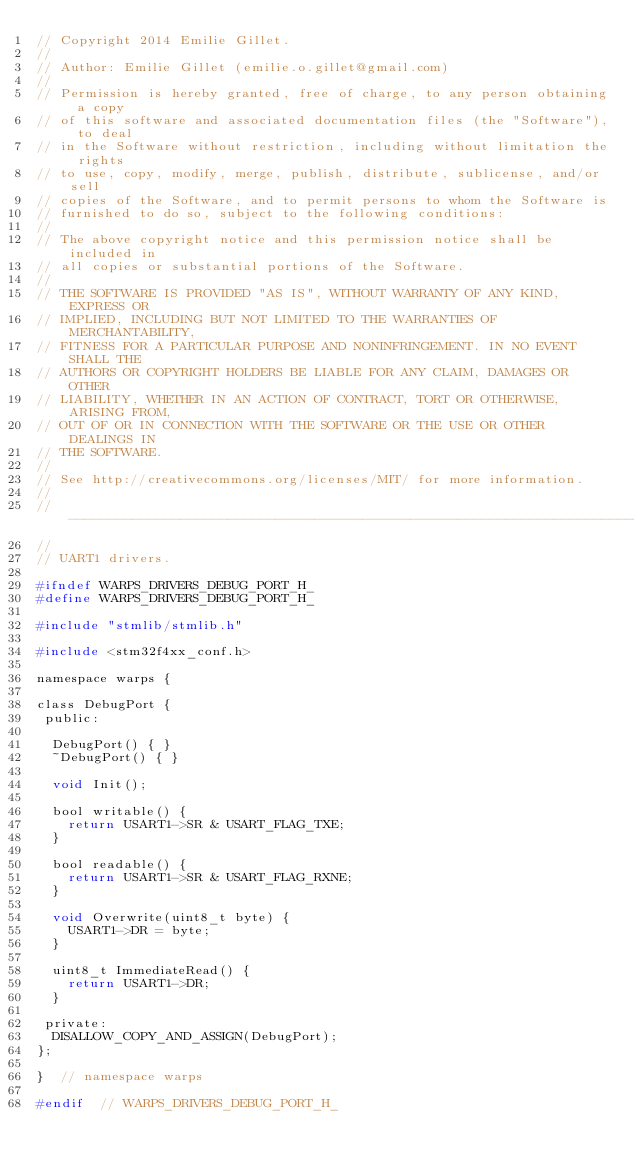<code> <loc_0><loc_0><loc_500><loc_500><_C_>// Copyright 2014 Emilie Gillet.
//
// Author: Emilie Gillet (emilie.o.gillet@gmail.com)
//
// Permission is hereby granted, free of charge, to any person obtaining a copy
// of this software and associated documentation files (the "Software"), to deal
// in the Software without restriction, including without limitation the rights
// to use, copy, modify, merge, publish, distribute, sublicense, and/or sell
// copies of the Software, and to permit persons to whom the Software is
// furnished to do so, subject to the following conditions:
// 
// The above copyright notice and this permission notice shall be included in
// all copies or substantial portions of the Software.
// 
// THE SOFTWARE IS PROVIDED "AS IS", WITHOUT WARRANTY OF ANY KIND, EXPRESS OR
// IMPLIED, INCLUDING BUT NOT LIMITED TO THE WARRANTIES OF MERCHANTABILITY,
// FITNESS FOR A PARTICULAR PURPOSE AND NONINFRINGEMENT. IN NO EVENT SHALL THE
// AUTHORS OR COPYRIGHT HOLDERS BE LIABLE FOR ANY CLAIM, DAMAGES OR OTHER
// LIABILITY, WHETHER IN AN ACTION OF CONTRACT, TORT OR OTHERWISE, ARISING FROM,
// OUT OF OR IN CONNECTION WITH THE SOFTWARE OR THE USE OR OTHER DEALINGS IN
// THE SOFTWARE.
// 
// See http://creativecommons.org/licenses/MIT/ for more information.
//
// -----------------------------------------------------------------------------
//
// UART1 drivers.

#ifndef WARPS_DRIVERS_DEBUG_PORT_H_
#define WARPS_DRIVERS_DEBUG_PORT_H_

#include "stmlib/stmlib.h"

#include <stm32f4xx_conf.h>

namespace warps {

class DebugPort {
 public:
  
  DebugPort() { }
  ~DebugPort() { }
  
  void Init();
  
  bool writable() {
    return USART1->SR & USART_FLAG_TXE;
  }
  
  bool readable() {
    return USART1->SR & USART_FLAG_RXNE;
  }
  
  void Overwrite(uint8_t byte) {
    USART1->DR = byte;
  }
  
  uint8_t ImmediateRead() {
    return USART1->DR;
  }
  
 private:
  DISALLOW_COPY_AND_ASSIGN(DebugPort);
};

}  // namespace warps

#endif  // WARPS_DRIVERS_DEBUG_PORT_H_
</code> 